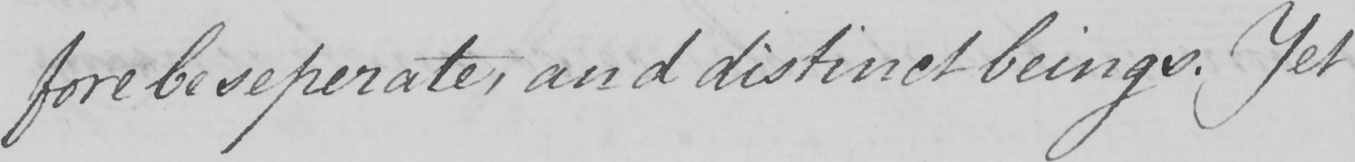Can you tell me what this handwritten text says? -fore be seperate , and distinct beings . Yet 